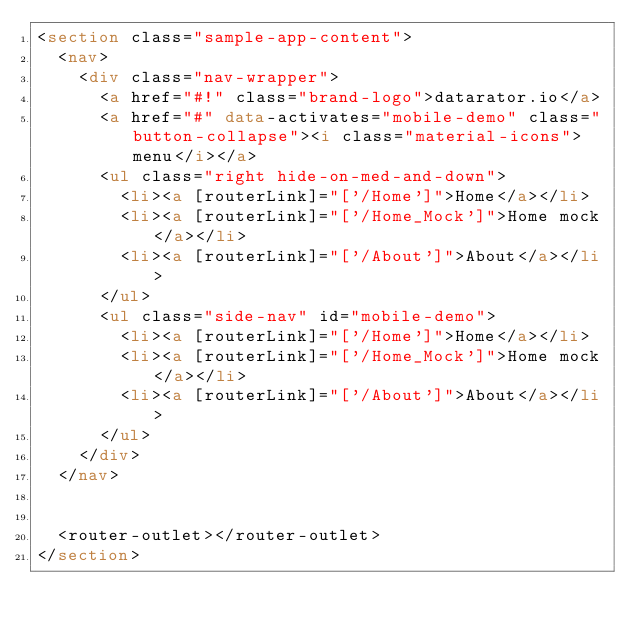<code> <loc_0><loc_0><loc_500><loc_500><_HTML_><section class="sample-app-content">
  <nav>
    <div class="nav-wrapper">
      <a href="#!" class="brand-logo">datarator.io</a>
      <a href="#" data-activates="mobile-demo" class="button-collapse"><i class="material-icons">menu</i></a>
      <ul class="right hide-on-med-and-down">
        <li><a [routerLink]="['/Home']">Home</a></li>
        <li><a [routerLink]="['/Home_Mock']">Home mock</a></li>
        <li><a [routerLink]="['/About']">About</a></li>
      </ul>
      <ul class="side-nav" id="mobile-demo">
        <li><a [routerLink]="['/Home']">Home</a></li>
        <li><a [routerLink]="['/Home_Mock']">Home mock</a></li>
        <li><a [routerLink]="['/About']">About</a></li>
      </ul>
    </div>
  </nav>


  <router-outlet></router-outlet>
</section>
</code> 